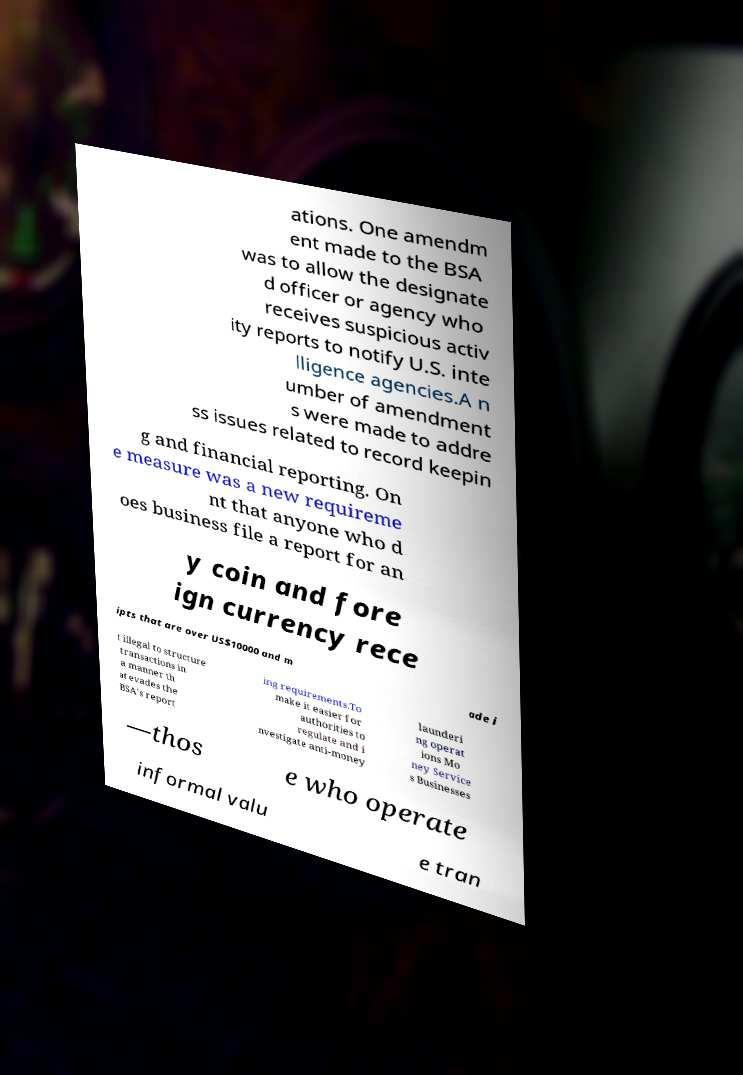Can you read and provide the text displayed in the image?This photo seems to have some interesting text. Can you extract and type it out for me? ations. One amendm ent made to the BSA was to allow the designate d officer or agency who receives suspicious activ ity reports to notify U.S. inte lligence agencies.A n umber of amendment s were made to addre ss issues related to record keepin g and financial reporting. On e measure was a new requireme nt that anyone who d oes business file a report for an y coin and fore ign currency rece ipts that are over US$10000 and m ade i t illegal to structure transactions in a manner th at evades the BSA's report ing requirements.To make it easier for authorities to regulate and i nvestigate anti-money launderi ng operat ions Mo ney Service s Businesses —thos e who operate informal valu e tran 